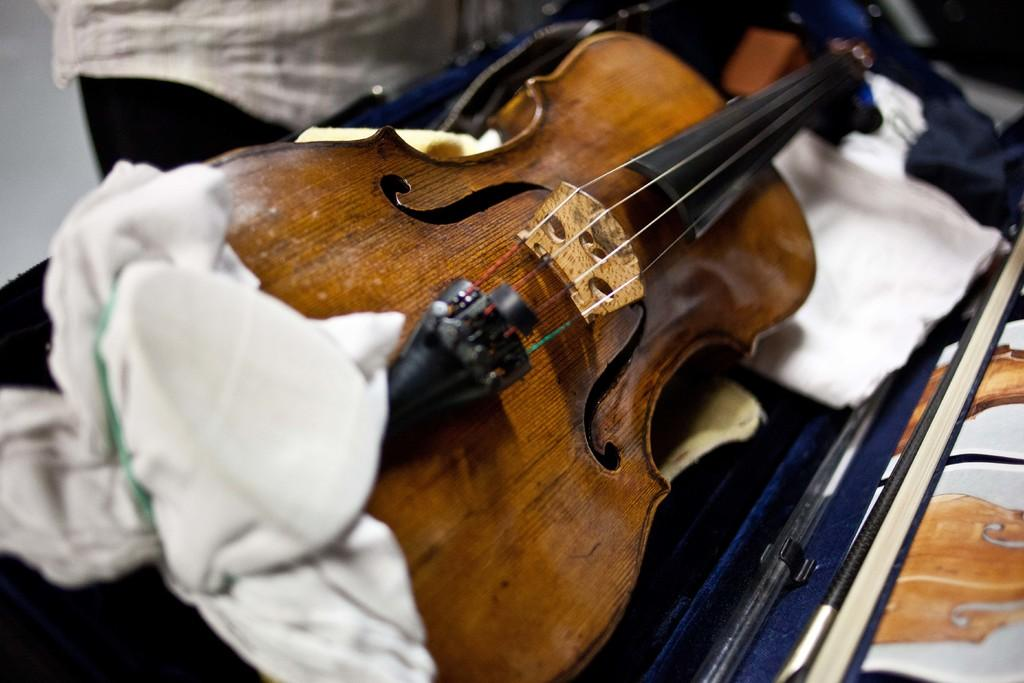What musical instrument is present in the image? There is a guitar in the image. How is the guitar being transported or stored? The guitar is on a guitar bag. Is there anyone near the guitar in the image? Yes, there is a person standing beside the guitar. What attempt is the minister making in the image? There is no minister or any attempt visible in the image; it only features a guitar on a guitar bag and a person standing nearby. 